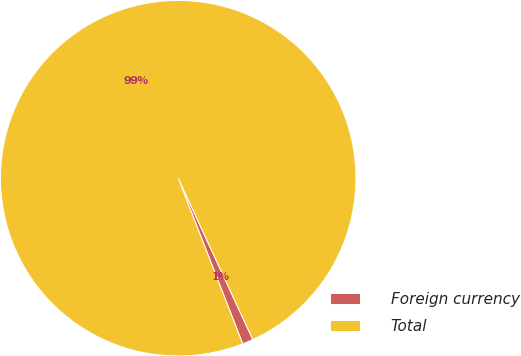Convert chart to OTSL. <chart><loc_0><loc_0><loc_500><loc_500><pie_chart><fcel>Foreign currency<fcel>Total<nl><fcel>0.98%<fcel>99.02%<nl></chart> 